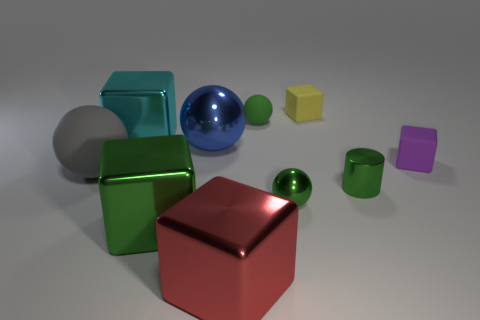Are the yellow block and the small green object behind the purple matte cube made of the same material?
Make the answer very short. Yes. There is a big block that is behind the big green thing; is there a rubber ball behind it?
Your response must be concise. Yes. There is a sphere that is on the left side of the big red metallic object and behind the gray thing; what color is it?
Make the answer very short. Blue. How big is the yellow thing?
Offer a very short reply. Small. What number of cyan metal blocks have the same size as the cylinder?
Provide a succinct answer. 0. Is the material of the green ball behind the gray rubber ball the same as the green thing that is left of the red cube?
Provide a short and direct response. No. What is the tiny green thing right of the metallic ball that is to the right of the tiny green rubber sphere made of?
Offer a very short reply. Metal. There is a cube right of the small yellow rubber thing; what is it made of?
Your response must be concise. Rubber. What number of green rubber things are the same shape as the large cyan metallic object?
Make the answer very short. 0. Do the cylinder and the small matte ball have the same color?
Give a very brief answer. Yes. 